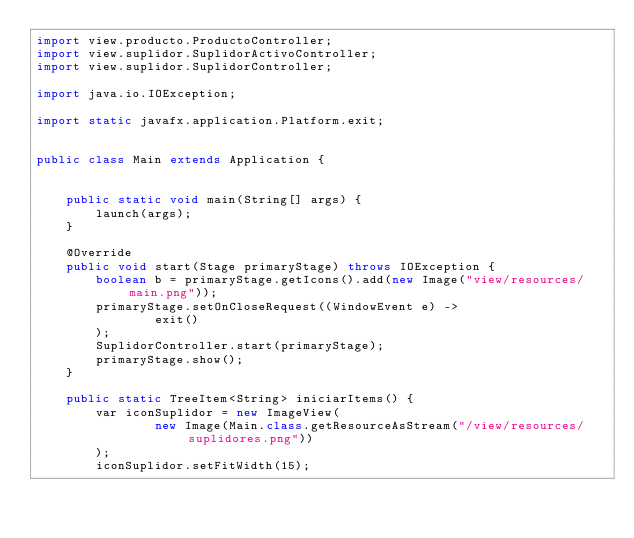Convert code to text. <code><loc_0><loc_0><loc_500><loc_500><_Java_>import view.producto.ProductoController;
import view.suplidor.SuplidorActivoController;
import view.suplidor.SuplidorController;

import java.io.IOException;

import static javafx.application.Platform.exit;


public class Main extends Application {


    public static void main(String[] args) {
        launch(args);
    }

    @Override
    public void start(Stage primaryStage) throws IOException {
        boolean b = primaryStage.getIcons().add(new Image("view/resources/main.png"));
        primaryStage.setOnCloseRequest((WindowEvent e) ->
                exit()
        );
        SuplidorController.start(primaryStage);
        primaryStage.show();
    }

    public static TreeItem<String> iniciarItems() {
        var iconSuplidor = new ImageView(
                new Image(Main.class.getResourceAsStream("/view/resources/suplidores.png"))
        );
        iconSuplidor.setFitWidth(15);</code> 